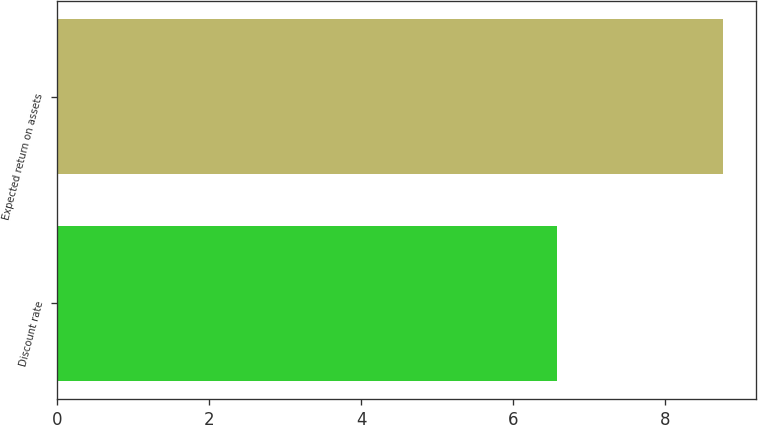<chart> <loc_0><loc_0><loc_500><loc_500><bar_chart><fcel>Discount rate<fcel>Expected return on assets<nl><fcel>6.58<fcel>8.75<nl></chart> 